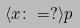<formula> <loc_0><loc_0><loc_500><loc_500>\langle x \colon = ? \rangle p</formula> 